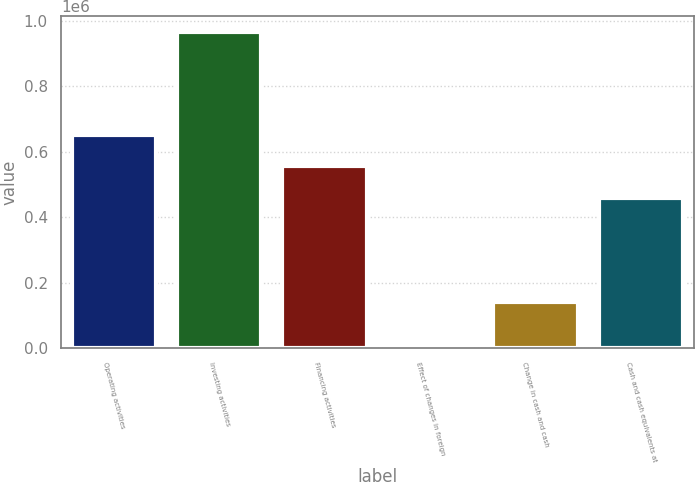<chart> <loc_0><loc_0><loc_500><loc_500><bar_chart><fcel>Operating activities<fcel>Investing activities<fcel>Financing activities<fcel>Effect of changes in foreign<fcel>Change in cash and cash<fcel>Cash and cash equivalents at<nl><fcel>651784<fcel>966641<fcel>556015<fcel>8944<fcel>141076<fcel>460245<nl></chart> 